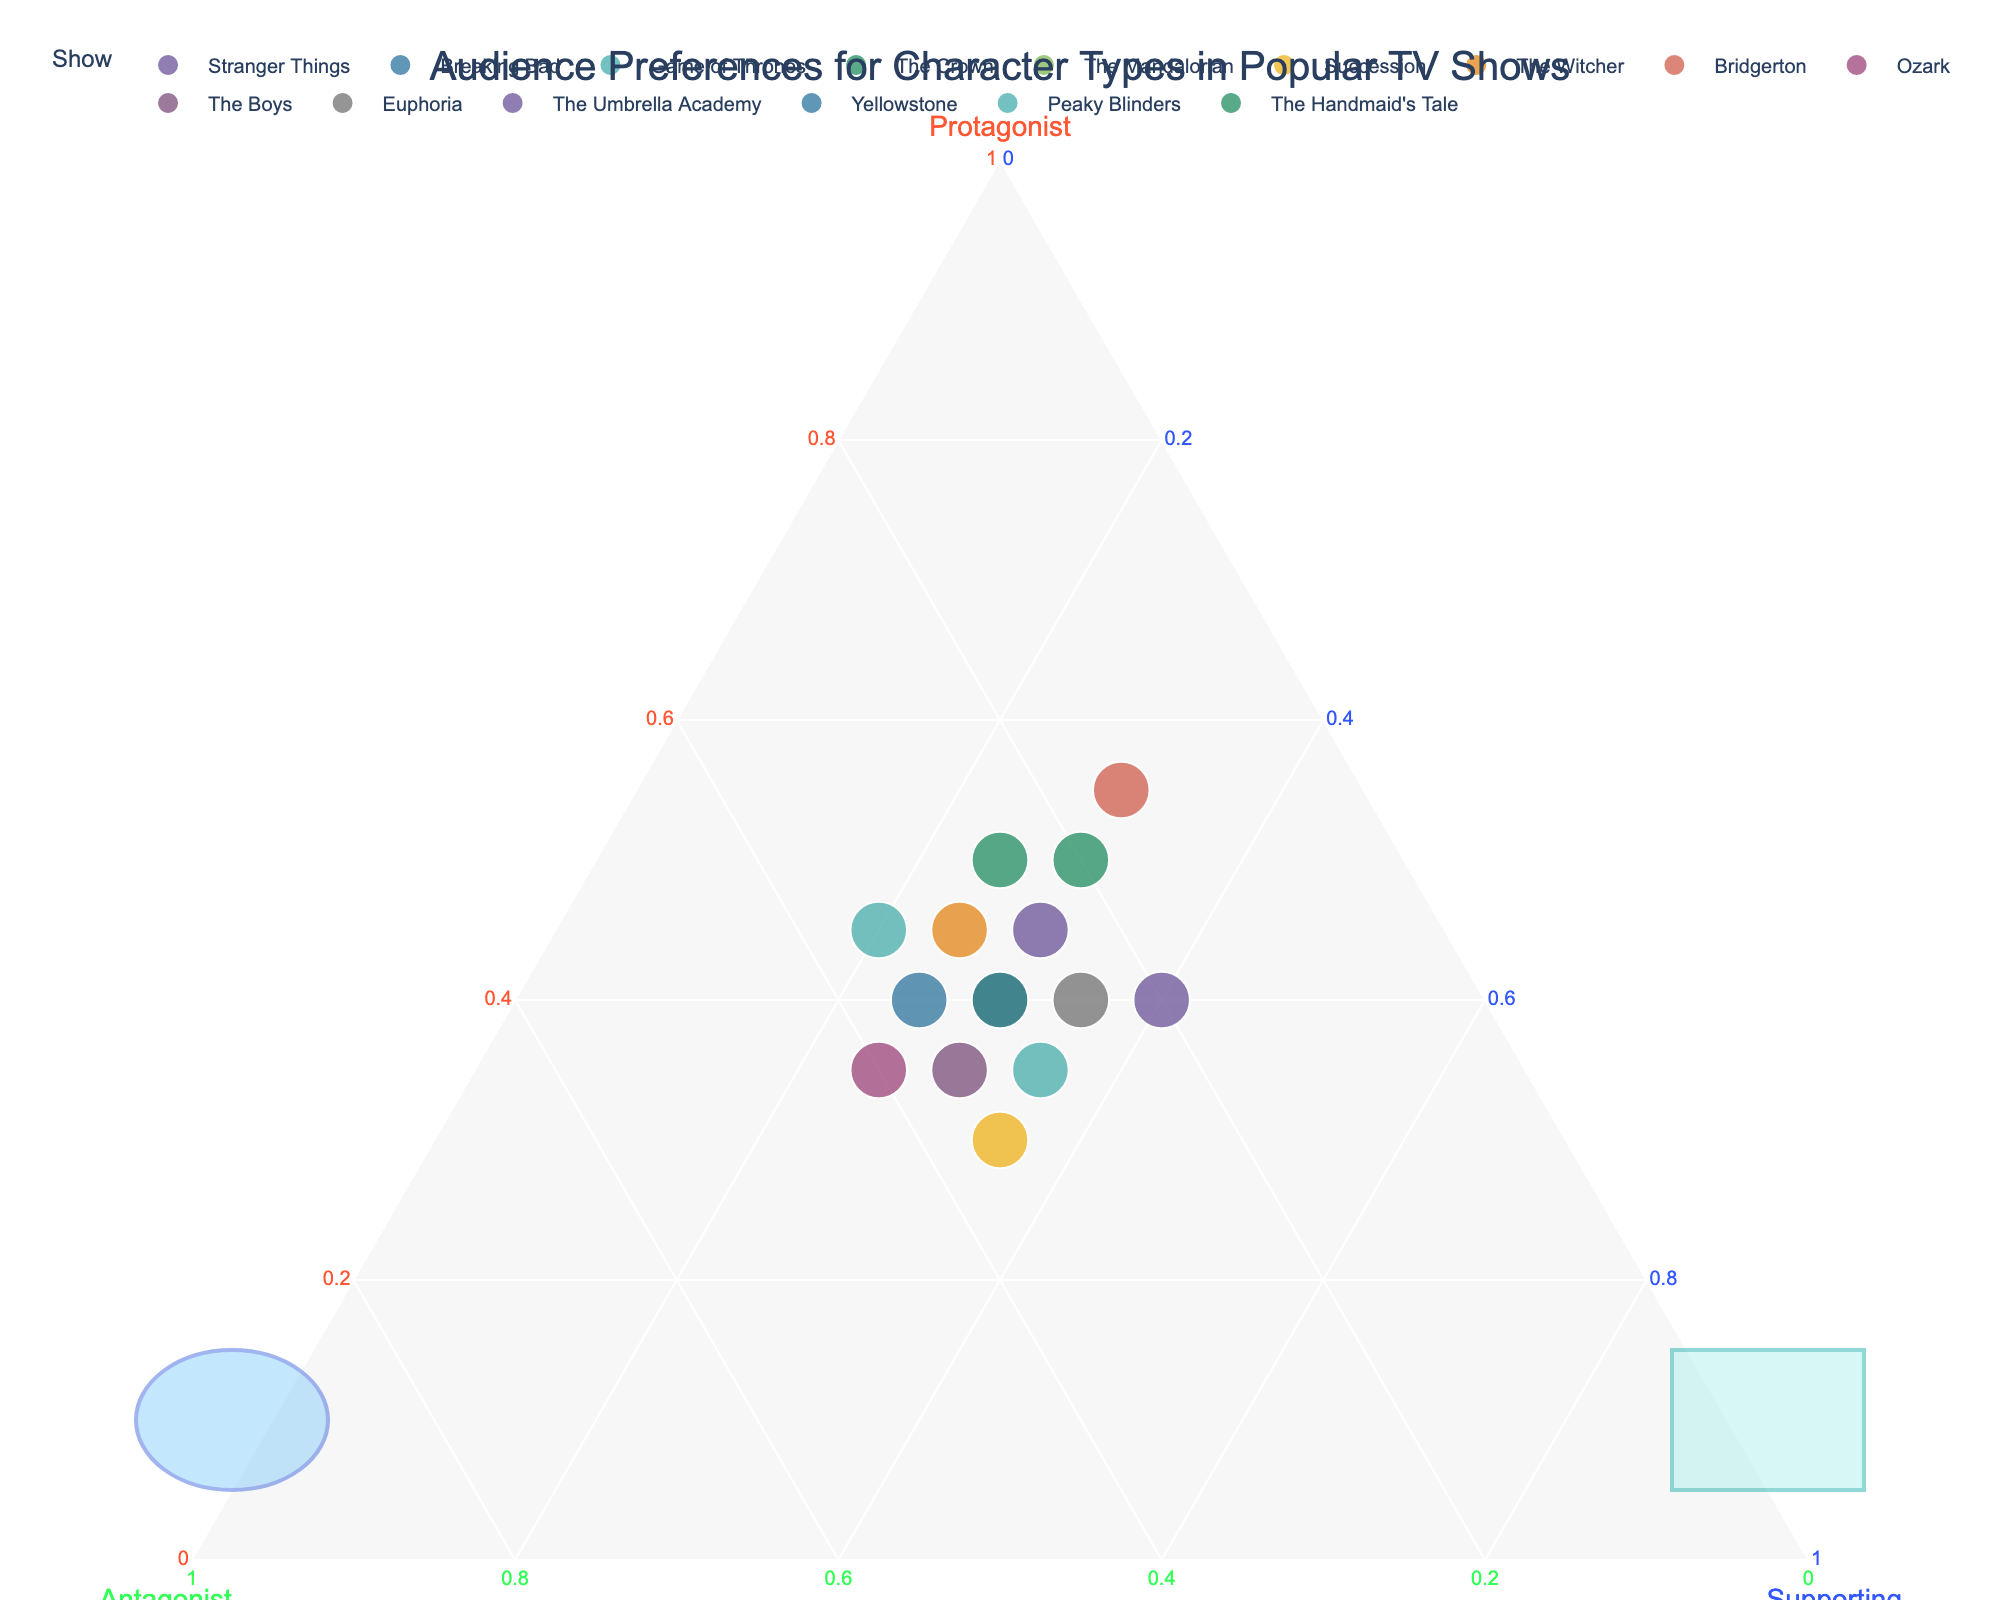What is the title of the plot? The title of the plot is prominently displayed at the top, summing up the overall theme.
Answer: Audience Preferences for Character Types in Popular TV Shows How many data points are represented in the plot? Count the number of different shows listed. Each show corresponds to one data point.
Answer: 15 Which show has the highest interest in protagonists? Look for the show with the highest proportion along the 'Protagonist' axis.
Answer: Bridgerton Which show has the smallest proportion of antagonists? Identify the data point closest to the 'Supporting' and 'Protagonist' axes, farthest from the 'Antagonist' axis.
Answer: Bridgerton Which two shows have the same proportion of supporting roles? Check which shows share the same position along the 'Supporting' axis.
Answer: Game of Thrones and Succession What is the average proportion of protagonists across all shows? Sum up the normalized 'Protagonist' values of all shows and then divide by the number of shows (15).
Answer: 0.4333 (rounded to 4 decimal places) Which show is closest to the center of the plot? Find the data point that is approximately equidistant from the 'Protagonist,' 'Antagonist,' and 'Supporting' axes, indicating equal proportions.
Answer: The Umbrella Academy Between 'Breaking Bad' and 'The Crown,' which has a higher proportion of antagonists? Compare the 'Antagonist' values of both shows using their respective positions along the 'Antagonist' axis.
Answer: Breaking Bad Which show falls within the custom circle shape on the plot? Identify the data point(s) enclosed by the custom circle shape referenced on the plot.
Answer: None Which shows have an equal split between protagonist and supporting roles? Look for data points where the 'Protagonist' and 'Supporting' normalized values are identical.
Answer: Yellowstone and The Mandalorian 